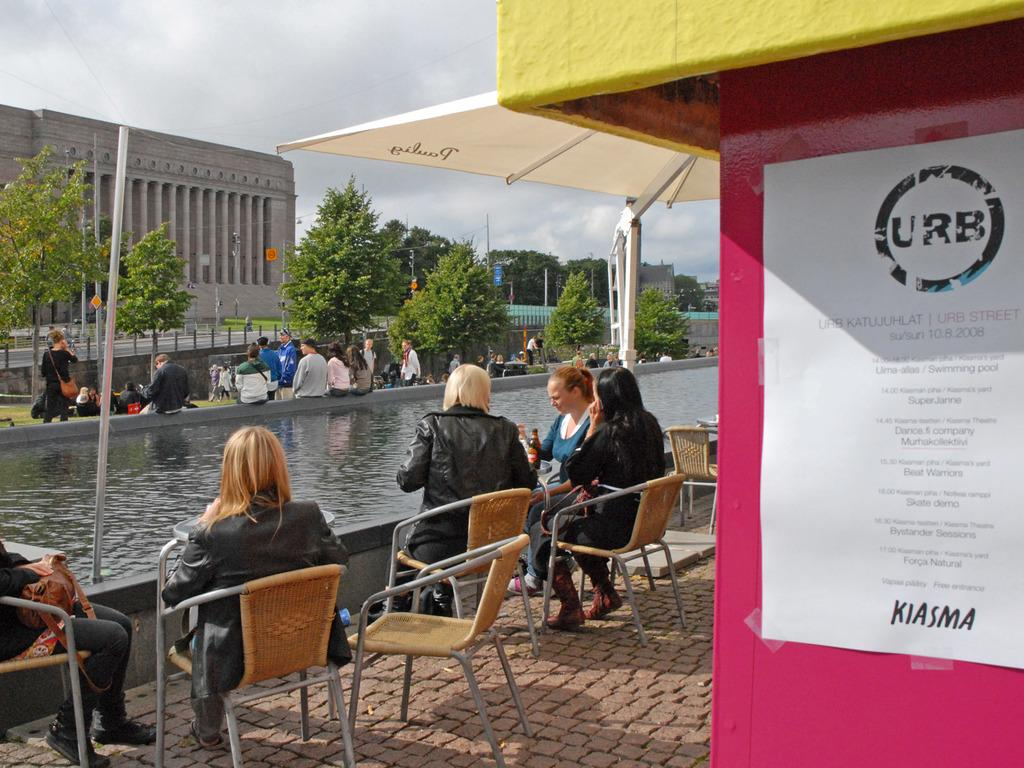How many women are sitting on the chair in the image? There are five women sitting on a chair in the image. What can be seen in the background of the image? There is water, a building, trees, and the sky visible in the image. Can you describe the people in the image? There are people in the image, specifically five women sitting on a chair. What type of caption is written on the wrench in the image? There is no wrench present in the image, so it is not possible to answer that question. 